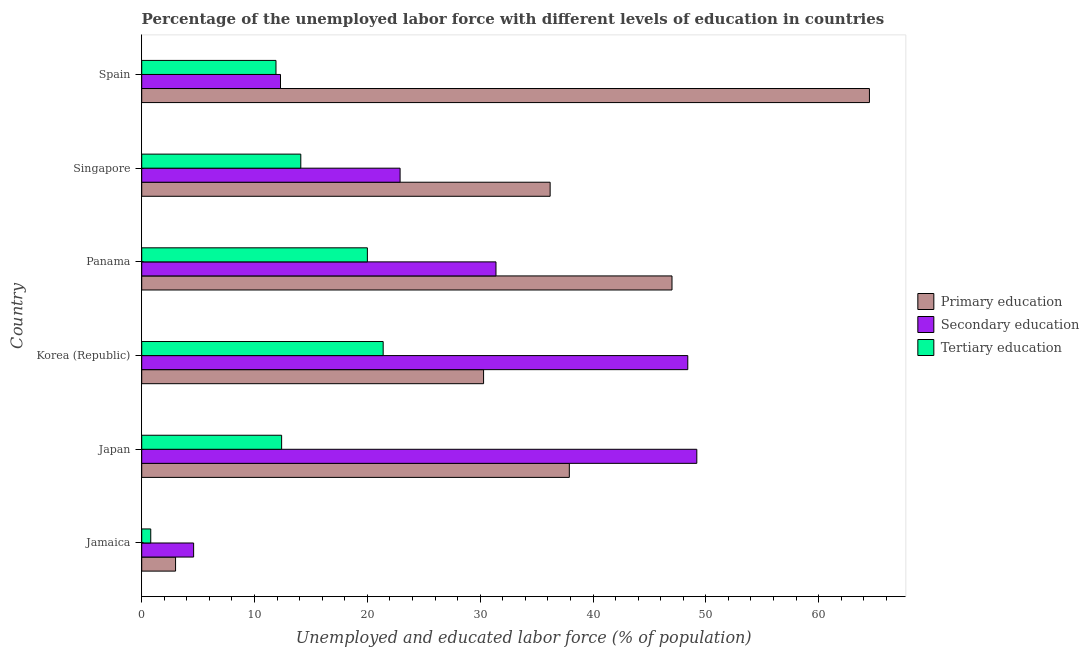How many different coloured bars are there?
Keep it short and to the point. 3. How many groups of bars are there?
Your answer should be very brief. 6. Are the number of bars per tick equal to the number of legend labels?
Make the answer very short. Yes. How many bars are there on the 2nd tick from the bottom?
Your answer should be compact. 3. What is the label of the 2nd group of bars from the top?
Offer a very short reply. Singapore. What is the percentage of labor force who received secondary education in Panama?
Offer a very short reply. 31.4. Across all countries, what is the maximum percentage of labor force who received tertiary education?
Ensure brevity in your answer.  21.4. Across all countries, what is the minimum percentage of labor force who received tertiary education?
Your answer should be very brief. 0.8. In which country was the percentage of labor force who received tertiary education minimum?
Ensure brevity in your answer.  Jamaica. What is the total percentage of labor force who received tertiary education in the graph?
Offer a very short reply. 80.6. What is the difference between the percentage of labor force who received primary education in Panama and the percentage of labor force who received secondary education in Korea (Republic)?
Ensure brevity in your answer.  -1.4. What is the average percentage of labor force who received secondary education per country?
Provide a succinct answer. 28.13. In how many countries, is the percentage of labor force who received tertiary education greater than 52 %?
Give a very brief answer. 0. What is the ratio of the percentage of labor force who received secondary education in Panama to that in Spain?
Ensure brevity in your answer.  2.55. Is the percentage of labor force who received secondary education in Japan less than that in Panama?
Offer a terse response. No. Is the difference between the percentage of labor force who received tertiary education in Jamaica and Singapore greater than the difference between the percentage of labor force who received primary education in Jamaica and Singapore?
Your answer should be very brief. Yes. What is the difference between the highest and the lowest percentage of labor force who received secondary education?
Your answer should be very brief. 44.6. In how many countries, is the percentage of labor force who received primary education greater than the average percentage of labor force who received primary education taken over all countries?
Your answer should be very brief. 3. What does the 3rd bar from the top in Jamaica represents?
Make the answer very short. Primary education. How many bars are there?
Make the answer very short. 18. How many countries are there in the graph?
Your answer should be very brief. 6. Does the graph contain any zero values?
Ensure brevity in your answer.  No. Does the graph contain grids?
Provide a succinct answer. No. How many legend labels are there?
Make the answer very short. 3. How are the legend labels stacked?
Make the answer very short. Vertical. What is the title of the graph?
Give a very brief answer. Percentage of the unemployed labor force with different levels of education in countries. What is the label or title of the X-axis?
Your answer should be very brief. Unemployed and educated labor force (% of population). What is the Unemployed and educated labor force (% of population) in Primary education in Jamaica?
Your answer should be compact. 3. What is the Unemployed and educated labor force (% of population) in Secondary education in Jamaica?
Provide a succinct answer. 4.6. What is the Unemployed and educated labor force (% of population) in Tertiary education in Jamaica?
Provide a succinct answer. 0.8. What is the Unemployed and educated labor force (% of population) of Primary education in Japan?
Provide a succinct answer. 37.9. What is the Unemployed and educated labor force (% of population) in Secondary education in Japan?
Give a very brief answer. 49.2. What is the Unemployed and educated labor force (% of population) in Tertiary education in Japan?
Offer a terse response. 12.4. What is the Unemployed and educated labor force (% of population) in Primary education in Korea (Republic)?
Ensure brevity in your answer.  30.3. What is the Unemployed and educated labor force (% of population) in Secondary education in Korea (Republic)?
Give a very brief answer. 48.4. What is the Unemployed and educated labor force (% of population) in Tertiary education in Korea (Republic)?
Offer a terse response. 21.4. What is the Unemployed and educated labor force (% of population) in Secondary education in Panama?
Your answer should be compact. 31.4. What is the Unemployed and educated labor force (% of population) of Primary education in Singapore?
Provide a succinct answer. 36.2. What is the Unemployed and educated labor force (% of population) in Secondary education in Singapore?
Your answer should be very brief. 22.9. What is the Unemployed and educated labor force (% of population) of Tertiary education in Singapore?
Give a very brief answer. 14.1. What is the Unemployed and educated labor force (% of population) of Primary education in Spain?
Make the answer very short. 64.5. What is the Unemployed and educated labor force (% of population) of Secondary education in Spain?
Make the answer very short. 12.3. What is the Unemployed and educated labor force (% of population) of Tertiary education in Spain?
Make the answer very short. 11.9. Across all countries, what is the maximum Unemployed and educated labor force (% of population) of Primary education?
Offer a terse response. 64.5. Across all countries, what is the maximum Unemployed and educated labor force (% of population) in Secondary education?
Offer a terse response. 49.2. Across all countries, what is the maximum Unemployed and educated labor force (% of population) of Tertiary education?
Make the answer very short. 21.4. Across all countries, what is the minimum Unemployed and educated labor force (% of population) in Secondary education?
Offer a very short reply. 4.6. Across all countries, what is the minimum Unemployed and educated labor force (% of population) in Tertiary education?
Your answer should be compact. 0.8. What is the total Unemployed and educated labor force (% of population) of Primary education in the graph?
Your response must be concise. 218.9. What is the total Unemployed and educated labor force (% of population) of Secondary education in the graph?
Your answer should be compact. 168.8. What is the total Unemployed and educated labor force (% of population) of Tertiary education in the graph?
Your response must be concise. 80.6. What is the difference between the Unemployed and educated labor force (% of population) of Primary education in Jamaica and that in Japan?
Offer a very short reply. -34.9. What is the difference between the Unemployed and educated labor force (% of population) in Secondary education in Jamaica and that in Japan?
Provide a succinct answer. -44.6. What is the difference between the Unemployed and educated labor force (% of population) of Primary education in Jamaica and that in Korea (Republic)?
Give a very brief answer. -27.3. What is the difference between the Unemployed and educated labor force (% of population) of Secondary education in Jamaica and that in Korea (Republic)?
Provide a succinct answer. -43.8. What is the difference between the Unemployed and educated labor force (% of population) in Tertiary education in Jamaica and that in Korea (Republic)?
Keep it short and to the point. -20.6. What is the difference between the Unemployed and educated labor force (% of population) in Primary education in Jamaica and that in Panama?
Your answer should be very brief. -44. What is the difference between the Unemployed and educated labor force (% of population) of Secondary education in Jamaica and that in Panama?
Your answer should be very brief. -26.8. What is the difference between the Unemployed and educated labor force (% of population) of Tertiary education in Jamaica and that in Panama?
Your response must be concise. -19.2. What is the difference between the Unemployed and educated labor force (% of population) in Primary education in Jamaica and that in Singapore?
Provide a short and direct response. -33.2. What is the difference between the Unemployed and educated labor force (% of population) of Secondary education in Jamaica and that in Singapore?
Provide a short and direct response. -18.3. What is the difference between the Unemployed and educated labor force (% of population) in Primary education in Jamaica and that in Spain?
Make the answer very short. -61.5. What is the difference between the Unemployed and educated labor force (% of population) in Secondary education in Jamaica and that in Spain?
Your response must be concise. -7.7. What is the difference between the Unemployed and educated labor force (% of population) of Tertiary education in Jamaica and that in Spain?
Your answer should be compact. -11.1. What is the difference between the Unemployed and educated labor force (% of population) of Secondary education in Japan and that in Korea (Republic)?
Keep it short and to the point. 0.8. What is the difference between the Unemployed and educated labor force (% of population) of Secondary education in Japan and that in Panama?
Your response must be concise. 17.8. What is the difference between the Unemployed and educated labor force (% of population) of Secondary education in Japan and that in Singapore?
Provide a succinct answer. 26.3. What is the difference between the Unemployed and educated labor force (% of population) of Primary education in Japan and that in Spain?
Your answer should be compact. -26.6. What is the difference between the Unemployed and educated labor force (% of population) in Secondary education in Japan and that in Spain?
Give a very brief answer. 36.9. What is the difference between the Unemployed and educated labor force (% of population) in Primary education in Korea (Republic) and that in Panama?
Offer a terse response. -16.7. What is the difference between the Unemployed and educated labor force (% of population) of Secondary education in Korea (Republic) and that in Panama?
Keep it short and to the point. 17. What is the difference between the Unemployed and educated labor force (% of population) in Tertiary education in Korea (Republic) and that in Panama?
Your answer should be very brief. 1.4. What is the difference between the Unemployed and educated labor force (% of population) of Primary education in Korea (Republic) and that in Singapore?
Keep it short and to the point. -5.9. What is the difference between the Unemployed and educated labor force (% of population) in Tertiary education in Korea (Republic) and that in Singapore?
Provide a short and direct response. 7.3. What is the difference between the Unemployed and educated labor force (% of population) in Primary education in Korea (Republic) and that in Spain?
Your answer should be compact. -34.2. What is the difference between the Unemployed and educated labor force (% of population) in Secondary education in Korea (Republic) and that in Spain?
Your answer should be very brief. 36.1. What is the difference between the Unemployed and educated labor force (% of population) in Secondary education in Panama and that in Singapore?
Make the answer very short. 8.5. What is the difference between the Unemployed and educated labor force (% of population) in Tertiary education in Panama and that in Singapore?
Give a very brief answer. 5.9. What is the difference between the Unemployed and educated labor force (% of population) in Primary education in Panama and that in Spain?
Your answer should be compact. -17.5. What is the difference between the Unemployed and educated labor force (% of population) of Secondary education in Panama and that in Spain?
Make the answer very short. 19.1. What is the difference between the Unemployed and educated labor force (% of population) in Tertiary education in Panama and that in Spain?
Your response must be concise. 8.1. What is the difference between the Unemployed and educated labor force (% of population) of Primary education in Singapore and that in Spain?
Offer a very short reply. -28.3. What is the difference between the Unemployed and educated labor force (% of population) in Primary education in Jamaica and the Unemployed and educated labor force (% of population) in Secondary education in Japan?
Your answer should be compact. -46.2. What is the difference between the Unemployed and educated labor force (% of population) of Secondary education in Jamaica and the Unemployed and educated labor force (% of population) of Tertiary education in Japan?
Offer a very short reply. -7.8. What is the difference between the Unemployed and educated labor force (% of population) of Primary education in Jamaica and the Unemployed and educated labor force (% of population) of Secondary education in Korea (Republic)?
Make the answer very short. -45.4. What is the difference between the Unemployed and educated labor force (% of population) in Primary education in Jamaica and the Unemployed and educated labor force (% of population) in Tertiary education in Korea (Republic)?
Your response must be concise. -18.4. What is the difference between the Unemployed and educated labor force (% of population) in Secondary education in Jamaica and the Unemployed and educated labor force (% of population) in Tertiary education in Korea (Republic)?
Provide a succinct answer. -16.8. What is the difference between the Unemployed and educated labor force (% of population) in Primary education in Jamaica and the Unemployed and educated labor force (% of population) in Secondary education in Panama?
Your answer should be compact. -28.4. What is the difference between the Unemployed and educated labor force (% of population) of Secondary education in Jamaica and the Unemployed and educated labor force (% of population) of Tertiary education in Panama?
Offer a very short reply. -15.4. What is the difference between the Unemployed and educated labor force (% of population) in Primary education in Jamaica and the Unemployed and educated labor force (% of population) in Secondary education in Singapore?
Your answer should be very brief. -19.9. What is the difference between the Unemployed and educated labor force (% of population) in Secondary education in Jamaica and the Unemployed and educated labor force (% of population) in Tertiary education in Singapore?
Offer a terse response. -9.5. What is the difference between the Unemployed and educated labor force (% of population) of Primary education in Jamaica and the Unemployed and educated labor force (% of population) of Tertiary education in Spain?
Offer a very short reply. -8.9. What is the difference between the Unemployed and educated labor force (% of population) of Primary education in Japan and the Unemployed and educated labor force (% of population) of Secondary education in Korea (Republic)?
Ensure brevity in your answer.  -10.5. What is the difference between the Unemployed and educated labor force (% of population) of Secondary education in Japan and the Unemployed and educated labor force (% of population) of Tertiary education in Korea (Republic)?
Offer a terse response. 27.8. What is the difference between the Unemployed and educated labor force (% of population) of Primary education in Japan and the Unemployed and educated labor force (% of population) of Tertiary education in Panama?
Give a very brief answer. 17.9. What is the difference between the Unemployed and educated labor force (% of population) in Secondary education in Japan and the Unemployed and educated labor force (% of population) in Tertiary education in Panama?
Offer a very short reply. 29.2. What is the difference between the Unemployed and educated labor force (% of population) in Primary education in Japan and the Unemployed and educated labor force (% of population) in Tertiary education in Singapore?
Offer a terse response. 23.8. What is the difference between the Unemployed and educated labor force (% of population) of Secondary education in Japan and the Unemployed and educated labor force (% of population) of Tertiary education in Singapore?
Your response must be concise. 35.1. What is the difference between the Unemployed and educated labor force (% of population) in Primary education in Japan and the Unemployed and educated labor force (% of population) in Secondary education in Spain?
Give a very brief answer. 25.6. What is the difference between the Unemployed and educated labor force (% of population) in Primary education in Japan and the Unemployed and educated labor force (% of population) in Tertiary education in Spain?
Provide a succinct answer. 26. What is the difference between the Unemployed and educated labor force (% of population) in Secondary education in Japan and the Unemployed and educated labor force (% of population) in Tertiary education in Spain?
Give a very brief answer. 37.3. What is the difference between the Unemployed and educated labor force (% of population) of Primary education in Korea (Republic) and the Unemployed and educated labor force (% of population) of Secondary education in Panama?
Keep it short and to the point. -1.1. What is the difference between the Unemployed and educated labor force (% of population) of Primary education in Korea (Republic) and the Unemployed and educated labor force (% of population) of Tertiary education in Panama?
Your response must be concise. 10.3. What is the difference between the Unemployed and educated labor force (% of population) in Secondary education in Korea (Republic) and the Unemployed and educated labor force (% of population) in Tertiary education in Panama?
Your answer should be very brief. 28.4. What is the difference between the Unemployed and educated labor force (% of population) of Primary education in Korea (Republic) and the Unemployed and educated labor force (% of population) of Secondary education in Singapore?
Your answer should be compact. 7.4. What is the difference between the Unemployed and educated labor force (% of population) of Secondary education in Korea (Republic) and the Unemployed and educated labor force (% of population) of Tertiary education in Singapore?
Provide a succinct answer. 34.3. What is the difference between the Unemployed and educated labor force (% of population) in Primary education in Korea (Republic) and the Unemployed and educated labor force (% of population) in Secondary education in Spain?
Your answer should be compact. 18. What is the difference between the Unemployed and educated labor force (% of population) in Primary education in Korea (Republic) and the Unemployed and educated labor force (% of population) in Tertiary education in Spain?
Your response must be concise. 18.4. What is the difference between the Unemployed and educated labor force (% of population) in Secondary education in Korea (Republic) and the Unemployed and educated labor force (% of population) in Tertiary education in Spain?
Offer a terse response. 36.5. What is the difference between the Unemployed and educated labor force (% of population) in Primary education in Panama and the Unemployed and educated labor force (% of population) in Secondary education in Singapore?
Your answer should be compact. 24.1. What is the difference between the Unemployed and educated labor force (% of population) in Primary education in Panama and the Unemployed and educated labor force (% of population) in Tertiary education in Singapore?
Your answer should be compact. 32.9. What is the difference between the Unemployed and educated labor force (% of population) in Secondary education in Panama and the Unemployed and educated labor force (% of population) in Tertiary education in Singapore?
Ensure brevity in your answer.  17.3. What is the difference between the Unemployed and educated labor force (% of population) in Primary education in Panama and the Unemployed and educated labor force (% of population) in Secondary education in Spain?
Give a very brief answer. 34.7. What is the difference between the Unemployed and educated labor force (% of population) of Primary education in Panama and the Unemployed and educated labor force (% of population) of Tertiary education in Spain?
Your response must be concise. 35.1. What is the difference between the Unemployed and educated labor force (% of population) of Primary education in Singapore and the Unemployed and educated labor force (% of population) of Secondary education in Spain?
Provide a short and direct response. 23.9. What is the difference between the Unemployed and educated labor force (% of population) of Primary education in Singapore and the Unemployed and educated labor force (% of population) of Tertiary education in Spain?
Offer a terse response. 24.3. What is the difference between the Unemployed and educated labor force (% of population) in Secondary education in Singapore and the Unemployed and educated labor force (% of population) in Tertiary education in Spain?
Offer a terse response. 11. What is the average Unemployed and educated labor force (% of population) in Primary education per country?
Your response must be concise. 36.48. What is the average Unemployed and educated labor force (% of population) of Secondary education per country?
Give a very brief answer. 28.13. What is the average Unemployed and educated labor force (% of population) of Tertiary education per country?
Keep it short and to the point. 13.43. What is the difference between the Unemployed and educated labor force (% of population) in Secondary education and Unemployed and educated labor force (% of population) in Tertiary education in Jamaica?
Keep it short and to the point. 3.8. What is the difference between the Unemployed and educated labor force (% of population) in Primary education and Unemployed and educated labor force (% of population) in Tertiary education in Japan?
Give a very brief answer. 25.5. What is the difference between the Unemployed and educated labor force (% of population) in Secondary education and Unemployed and educated labor force (% of population) in Tertiary education in Japan?
Make the answer very short. 36.8. What is the difference between the Unemployed and educated labor force (% of population) of Primary education and Unemployed and educated labor force (% of population) of Secondary education in Korea (Republic)?
Keep it short and to the point. -18.1. What is the difference between the Unemployed and educated labor force (% of population) of Primary education and Unemployed and educated labor force (% of population) of Tertiary education in Korea (Republic)?
Offer a terse response. 8.9. What is the difference between the Unemployed and educated labor force (% of population) in Secondary education and Unemployed and educated labor force (% of population) in Tertiary education in Korea (Republic)?
Offer a terse response. 27. What is the difference between the Unemployed and educated labor force (% of population) in Primary education and Unemployed and educated labor force (% of population) in Secondary education in Panama?
Your answer should be compact. 15.6. What is the difference between the Unemployed and educated labor force (% of population) in Primary education and Unemployed and educated labor force (% of population) in Tertiary education in Panama?
Your answer should be compact. 27. What is the difference between the Unemployed and educated labor force (% of population) in Secondary education and Unemployed and educated labor force (% of population) in Tertiary education in Panama?
Make the answer very short. 11.4. What is the difference between the Unemployed and educated labor force (% of population) of Primary education and Unemployed and educated labor force (% of population) of Secondary education in Singapore?
Your answer should be compact. 13.3. What is the difference between the Unemployed and educated labor force (% of population) of Primary education and Unemployed and educated labor force (% of population) of Tertiary education in Singapore?
Give a very brief answer. 22.1. What is the difference between the Unemployed and educated labor force (% of population) in Primary education and Unemployed and educated labor force (% of population) in Secondary education in Spain?
Offer a very short reply. 52.2. What is the difference between the Unemployed and educated labor force (% of population) of Primary education and Unemployed and educated labor force (% of population) of Tertiary education in Spain?
Offer a very short reply. 52.6. What is the ratio of the Unemployed and educated labor force (% of population) of Primary education in Jamaica to that in Japan?
Give a very brief answer. 0.08. What is the ratio of the Unemployed and educated labor force (% of population) of Secondary education in Jamaica to that in Japan?
Make the answer very short. 0.09. What is the ratio of the Unemployed and educated labor force (% of population) in Tertiary education in Jamaica to that in Japan?
Make the answer very short. 0.06. What is the ratio of the Unemployed and educated labor force (% of population) in Primary education in Jamaica to that in Korea (Republic)?
Provide a succinct answer. 0.1. What is the ratio of the Unemployed and educated labor force (% of population) in Secondary education in Jamaica to that in Korea (Republic)?
Provide a short and direct response. 0.1. What is the ratio of the Unemployed and educated labor force (% of population) in Tertiary education in Jamaica to that in Korea (Republic)?
Provide a short and direct response. 0.04. What is the ratio of the Unemployed and educated labor force (% of population) of Primary education in Jamaica to that in Panama?
Provide a short and direct response. 0.06. What is the ratio of the Unemployed and educated labor force (% of population) in Secondary education in Jamaica to that in Panama?
Provide a short and direct response. 0.15. What is the ratio of the Unemployed and educated labor force (% of population) in Tertiary education in Jamaica to that in Panama?
Offer a terse response. 0.04. What is the ratio of the Unemployed and educated labor force (% of population) of Primary education in Jamaica to that in Singapore?
Keep it short and to the point. 0.08. What is the ratio of the Unemployed and educated labor force (% of population) of Secondary education in Jamaica to that in Singapore?
Give a very brief answer. 0.2. What is the ratio of the Unemployed and educated labor force (% of population) in Tertiary education in Jamaica to that in Singapore?
Your answer should be very brief. 0.06. What is the ratio of the Unemployed and educated labor force (% of population) of Primary education in Jamaica to that in Spain?
Make the answer very short. 0.05. What is the ratio of the Unemployed and educated labor force (% of population) of Secondary education in Jamaica to that in Spain?
Make the answer very short. 0.37. What is the ratio of the Unemployed and educated labor force (% of population) of Tertiary education in Jamaica to that in Spain?
Your response must be concise. 0.07. What is the ratio of the Unemployed and educated labor force (% of population) of Primary education in Japan to that in Korea (Republic)?
Provide a short and direct response. 1.25. What is the ratio of the Unemployed and educated labor force (% of population) of Secondary education in Japan to that in Korea (Republic)?
Provide a short and direct response. 1.02. What is the ratio of the Unemployed and educated labor force (% of population) of Tertiary education in Japan to that in Korea (Republic)?
Offer a very short reply. 0.58. What is the ratio of the Unemployed and educated labor force (% of population) in Primary education in Japan to that in Panama?
Provide a succinct answer. 0.81. What is the ratio of the Unemployed and educated labor force (% of population) of Secondary education in Japan to that in Panama?
Offer a terse response. 1.57. What is the ratio of the Unemployed and educated labor force (% of population) of Tertiary education in Japan to that in Panama?
Offer a very short reply. 0.62. What is the ratio of the Unemployed and educated labor force (% of population) in Primary education in Japan to that in Singapore?
Make the answer very short. 1.05. What is the ratio of the Unemployed and educated labor force (% of population) of Secondary education in Japan to that in Singapore?
Offer a very short reply. 2.15. What is the ratio of the Unemployed and educated labor force (% of population) in Tertiary education in Japan to that in Singapore?
Give a very brief answer. 0.88. What is the ratio of the Unemployed and educated labor force (% of population) in Primary education in Japan to that in Spain?
Provide a short and direct response. 0.59. What is the ratio of the Unemployed and educated labor force (% of population) of Secondary education in Japan to that in Spain?
Keep it short and to the point. 4. What is the ratio of the Unemployed and educated labor force (% of population) in Tertiary education in Japan to that in Spain?
Give a very brief answer. 1.04. What is the ratio of the Unemployed and educated labor force (% of population) of Primary education in Korea (Republic) to that in Panama?
Keep it short and to the point. 0.64. What is the ratio of the Unemployed and educated labor force (% of population) of Secondary education in Korea (Republic) to that in Panama?
Keep it short and to the point. 1.54. What is the ratio of the Unemployed and educated labor force (% of population) in Tertiary education in Korea (Republic) to that in Panama?
Provide a short and direct response. 1.07. What is the ratio of the Unemployed and educated labor force (% of population) in Primary education in Korea (Republic) to that in Singapore?
Offer a terse response. 0.84. What is the ratio of the Unemployed and educated labor force (% of population) in Secondary education in Korea (Republic) to that in Singapore?
Provide a short and direct response. 2.11. What is the ratio of the Unemployed and educated labor force (% of population) in Tertiary education in Korea (Republic) to that in Singapore?
Your response must be concise. 1.52. What is the ratio of the Unemployed and educated labor force (% of population) of Primary education in Korea (Republic) to that in Spain?
Give a very brief answer. 0.47. What is the ratio of the Unemployed and educated labor force (% of population) of Secondary education in Korea (Republic) to that in Spain?
Your answer should be very brief. 3.94. What is the ratio of the Unemployed and educated labor force (% of population) of Tertiary education in Korea (Republic) to that in Spain?
Make the answer very short. 1.8. What is the ratio of the Unemployed and educated labor force (% of population) of Primary education in Panama to that in Singapore?
Give a very brief answer. 1.3. What is the ratio of the Unemployed and educated labor force (% of population) in Secondary education in Panama to that in Singapore?
Give a very brief answer. 1.37. What is the ratio of the Unemployed and educated labor force (% of population) of Tertiary education in Panama to that in Singapore?
Make the answer very short. 1.42. What is the ratio of the Unemployed and educated labor force (% of population) in Primary education in Panama to that in Spain?
Your answer should be very brief. 0.73. What is the ratio of the Unemployed and educated labor force (% of population) in Secondary education in Panama to that in Spain?
Your response must be concise. 2.55. What is the ratio of the Unemployed and educated labor force (% of population) of Tertiary education in Panama to that in Spain?
Keep it short and to the point. 1.68. What is the ratio of the Unemployed and educated labor force (% of population) in Primary education in Singapore to that in Spain?
Make the answer very short. 0.56. What is the ratio of the Unemployed and educated labor force (% of population) of Secondary education in Singapore to that in Spain?
Keep it short and to the point. 1.86. What is the ratio of the Unemployed and educated labor force (% of population) in Tertiary education in Singapore to that in Spain?
Your response must be concise. 1.18. What is the difference between the highest and the second highest Unemployed and educated labor force (% of population) in Tertiary education?
Keep it short and to the point. 1.4. What is the difference between the highest and the lowest Unemployed and educated labor force (% of population) of Primary education?
Your response must be concise. 61.5. What is the difference between the highest and the lowest Unemployed and educated labor force (% of population) of Secondary education?
Offer a very short reply. 44.6. What is the difference between the highest and the lowest Unemployed and educated labor force (% of population) in Tertiary education?
Provide a short and direct response. 20.6. 